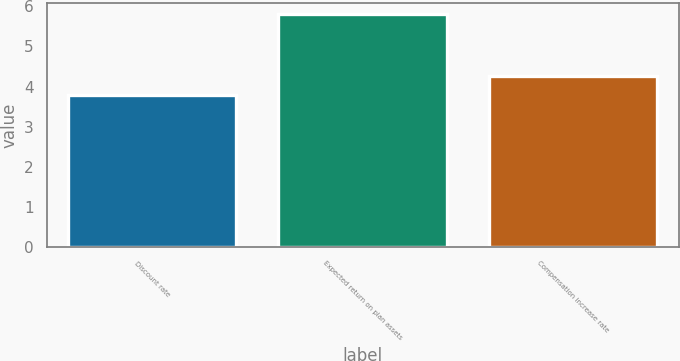<chart> <loc_0><loc_0><loc_500><loc_500><bar_chart><fcel>Discount rate<fcel>Expected return on plan assets<fcel>Compensation increase rate<nl><fcel>3.8<fcel>5.8<fcel>4.25<nl></chart> 